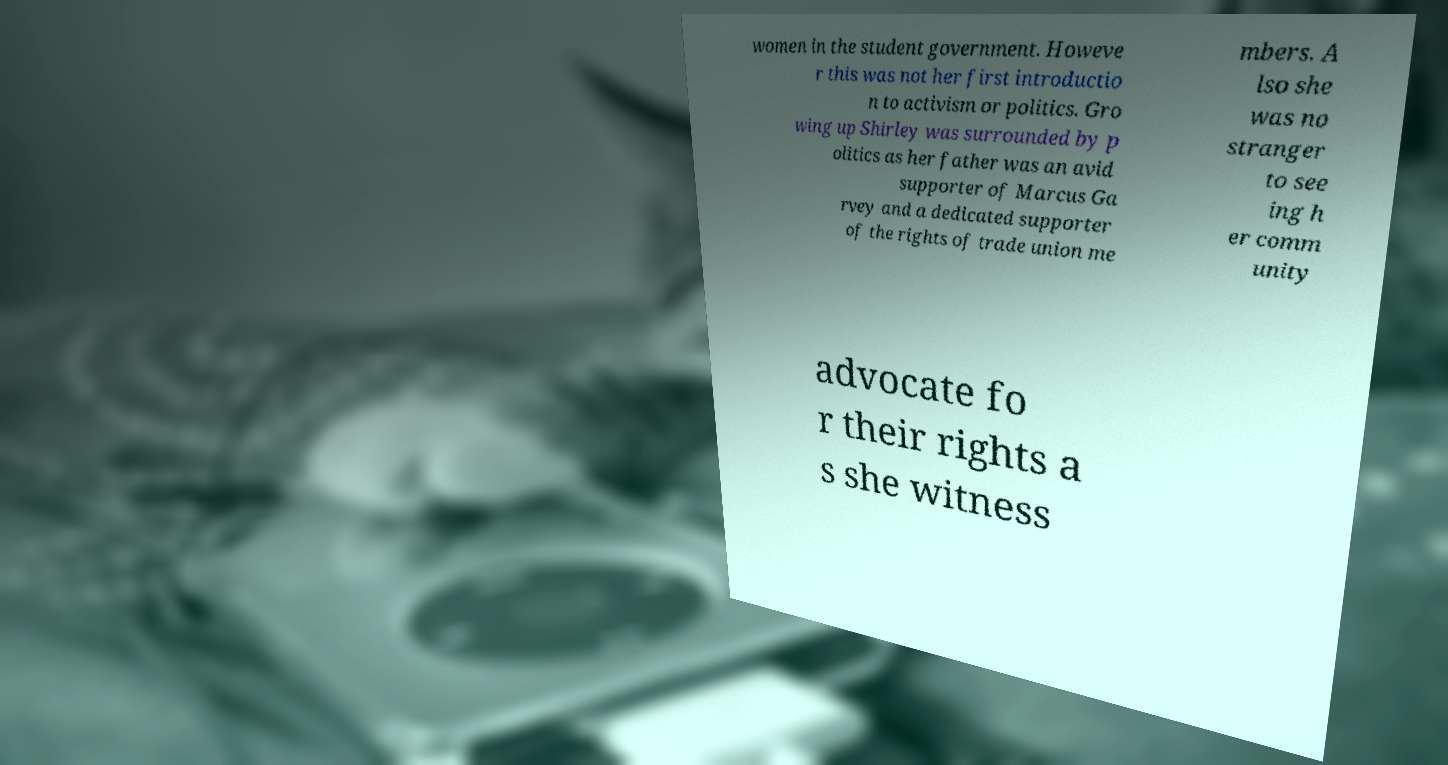What messages or text are displayed in this image? I need them in a readable, typed format. women in the student government. Howeve r this was not her first introductio n to activism or politics. Gro wing up Shirley was surrounded by p olitics as her father was an avid supporter of Marcus Ga rvey and a dedicated supporter of the rights of trade union me mbers. A lso she was no stranger to see ing h er comm unity advocate fo r their rights a s she witness 